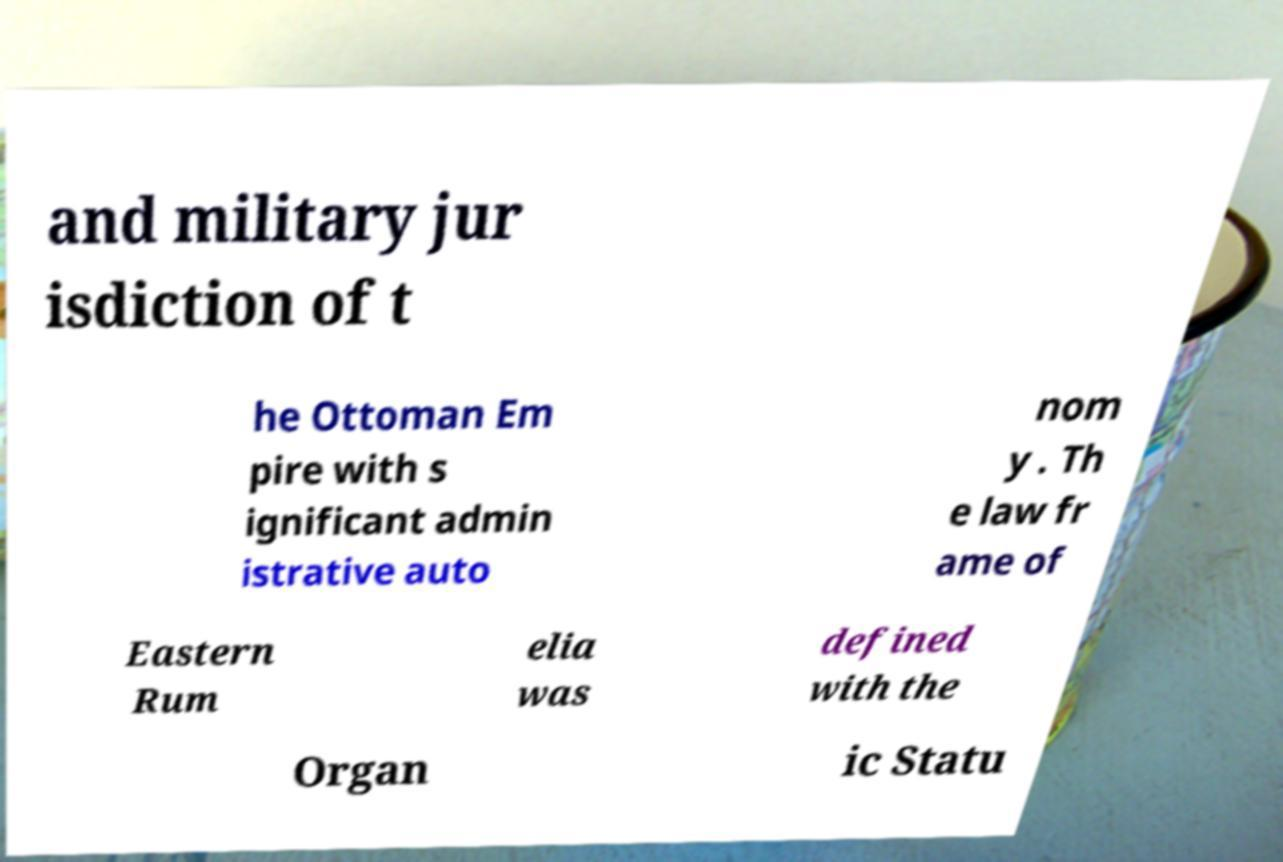I need the written content from this picture converted into text. Can you do that? and military jur isdiction of t he Ottoman Em pire with s ignificant admin istrative auto nom y . Th e law fr ame of Eastern Rum elia was defined with the Organ ic Statu 